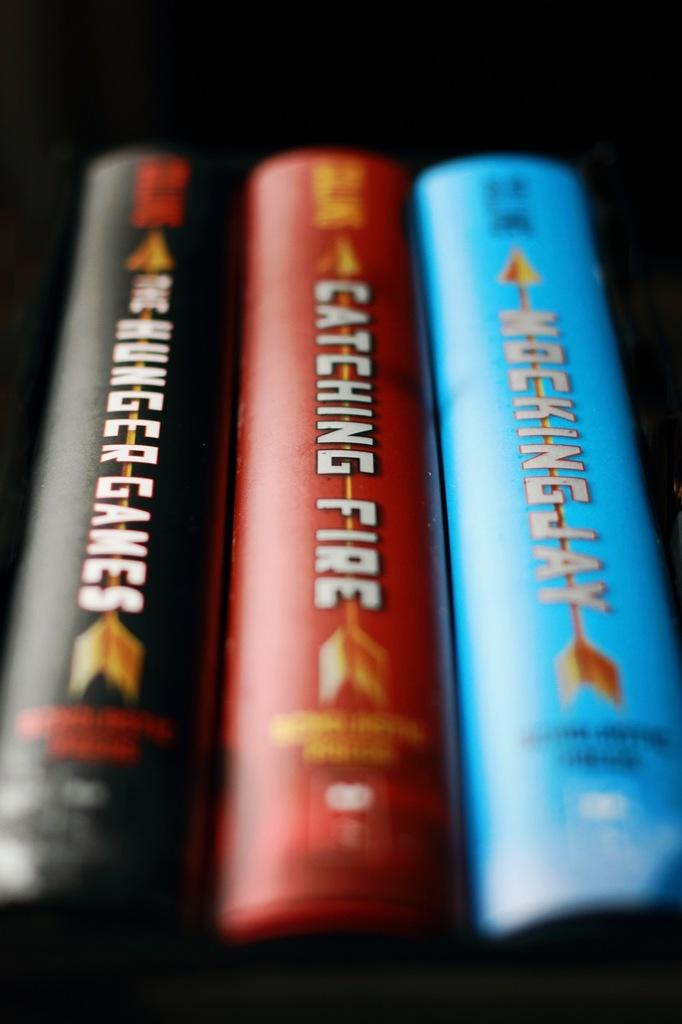What is the name of the blue book?
Offer a terse response. Mockingjay. What is the name of the red book?
Your response must be concise. Catching fire. 